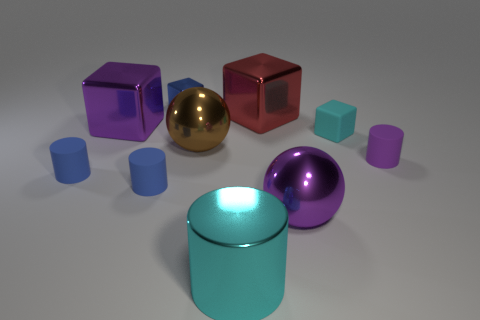Subtract all tiny matte cylinders. How many cylinders are left? 1 Subtract all cyan cylinders. How many cylinders are left? 3 Subtract 2 cylinders. How many cylinders are left? 2 Subtract all cyan cylinders. Subtract all blue blocks. How many cylinders are left? 3 Subtract all cylinders. How many objects are left? 6 Subtract 1 purple blocks. How many objects are left? 9 Subtract all big yellow rubber things. Subtract all big objects. How many objects are left? 5 Add 3 brown objects. How many brown objects are left? 4 Add 3 large cyan cylinders. How many large cyan cylinders exist? 4 